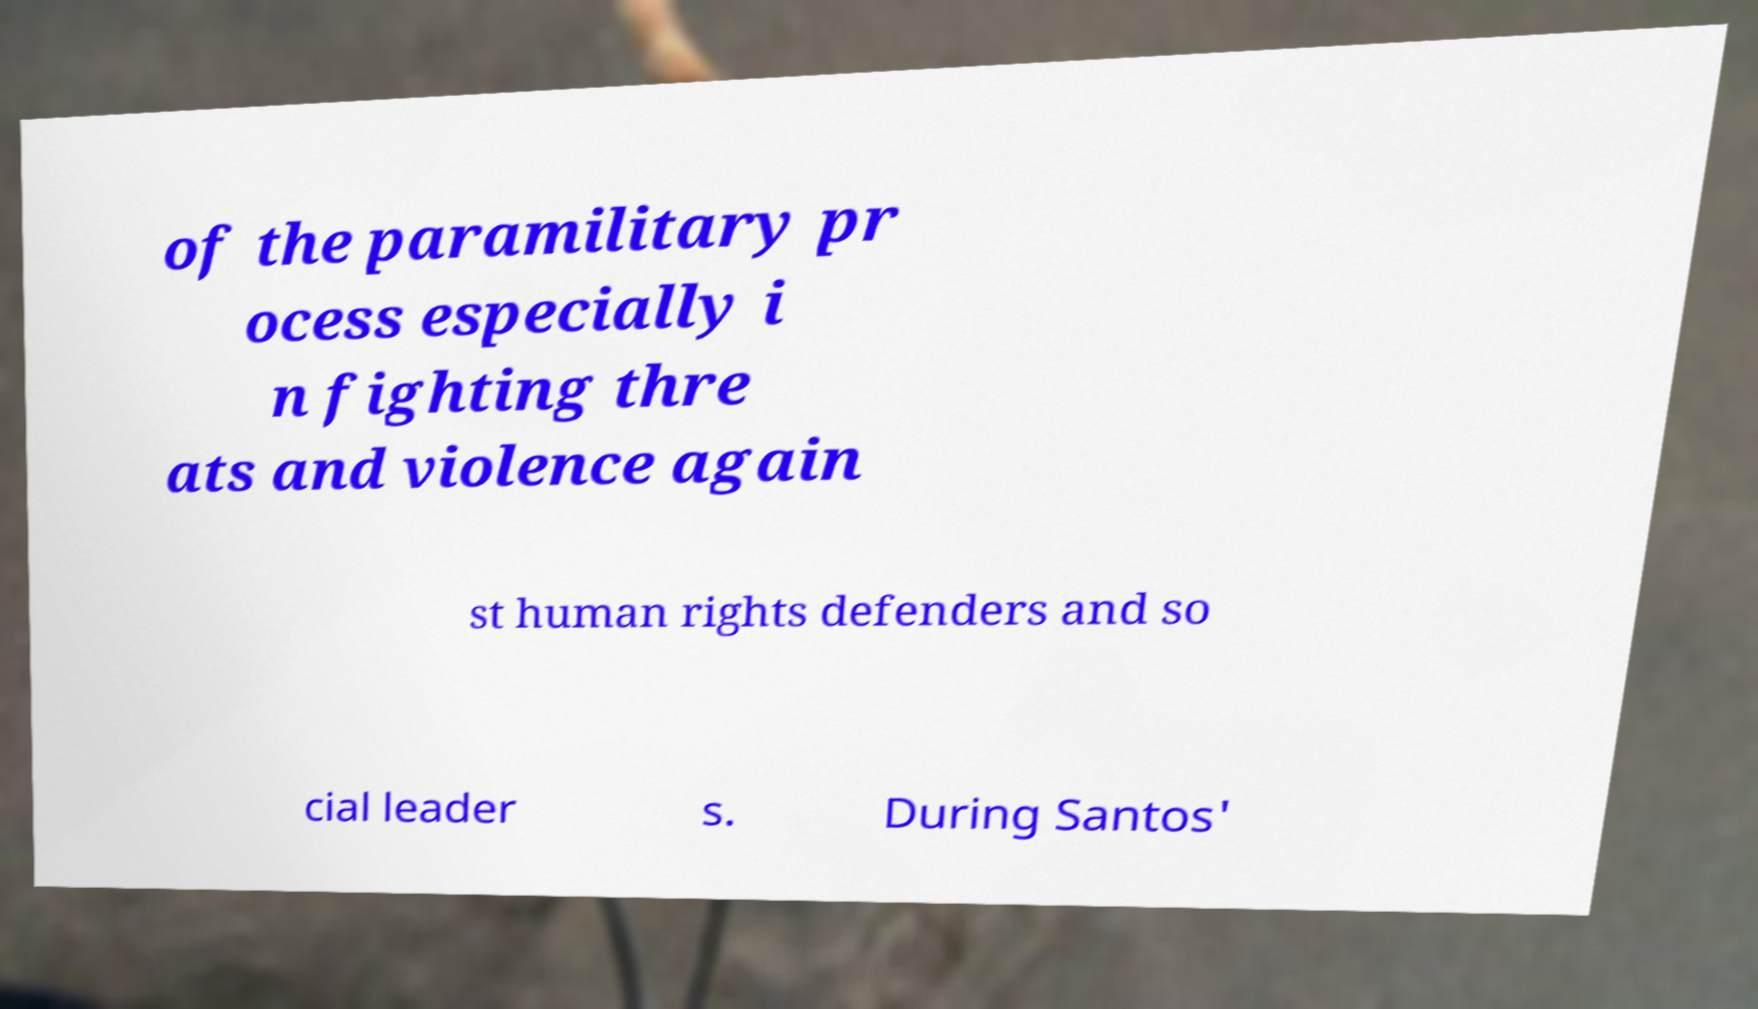Can you accurately transcribe the text from the provided image for me? of the paramilitary pr ocess especially i n fighting thre ats and violence again st human rights defenders and so cial leader s. During Santos' 